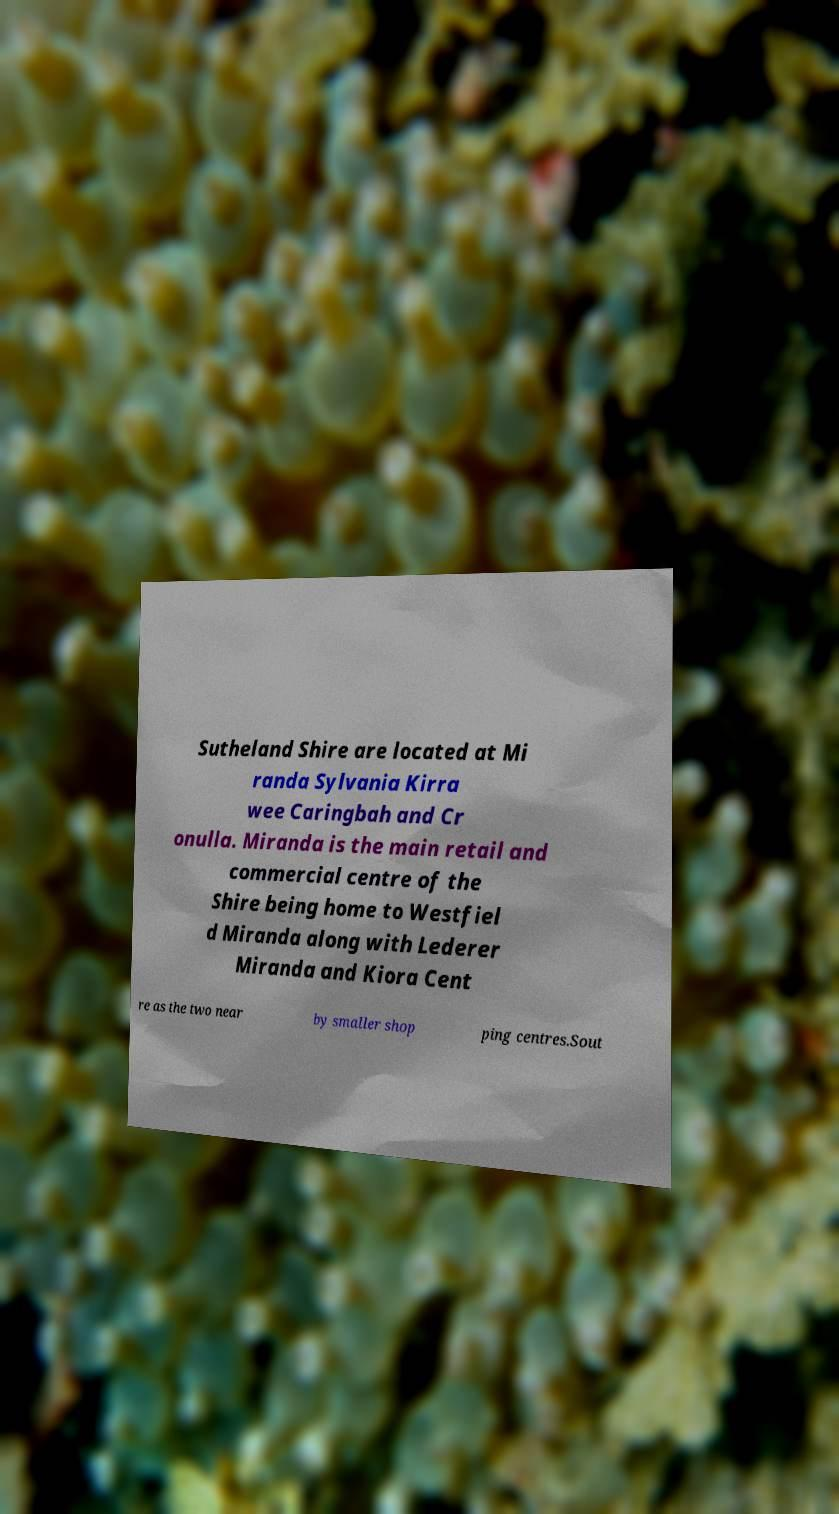For documentation purposes, I need the text within this image transcribed. Could you provide that? Sutheland Shire are located at Mi randa Sylvania Kirra wee Caringbah and Cr onulla. Miranda is the main retail and commercial centre of the Shire being home to Westfiel d Miranda along with Lederer Miranda and Kiora Cent re as the two near by smaller shop ping centres.Sout 